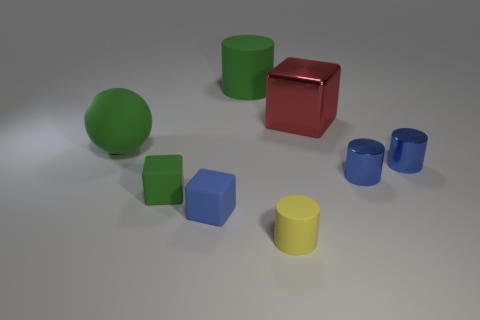Is there a tiny purple thing?
Ensure brevity in your answer.  No. There is a rubber cylinder in front of the large thing to the left of the cylinder on the left side of the small yellow cylinder; what is its color?
Offer a terse response. Yellow. There is a big green object on the right side of the large rubber ball; is there a cube that is to the left of it?
Provide a short and direct response. Yes. Does the large matte thing that is behind the red metal cube have the same color as the rubber cylinder that is in front of the red object?
Provide a succinct answer. No. What number of other things are the same size as the yellow matte object?
Give a very brief answer. 4. Do the blue object that is left of the metallic cube and the big green rubber sphere have the same size?
Provide a short and direct response. No. There is a yellow object; what shape is it?
Ensure brevity in your answer.  Cylinder. The block that is the same color as the ball is what size?
Provide a short and direct response. Small. Do the green object in front of the ball and the blue cube have the same material?
Your response must be concise. Yes. Is there a tiny object that has the same color as the large cube?
Your answer should be very brief. No. 